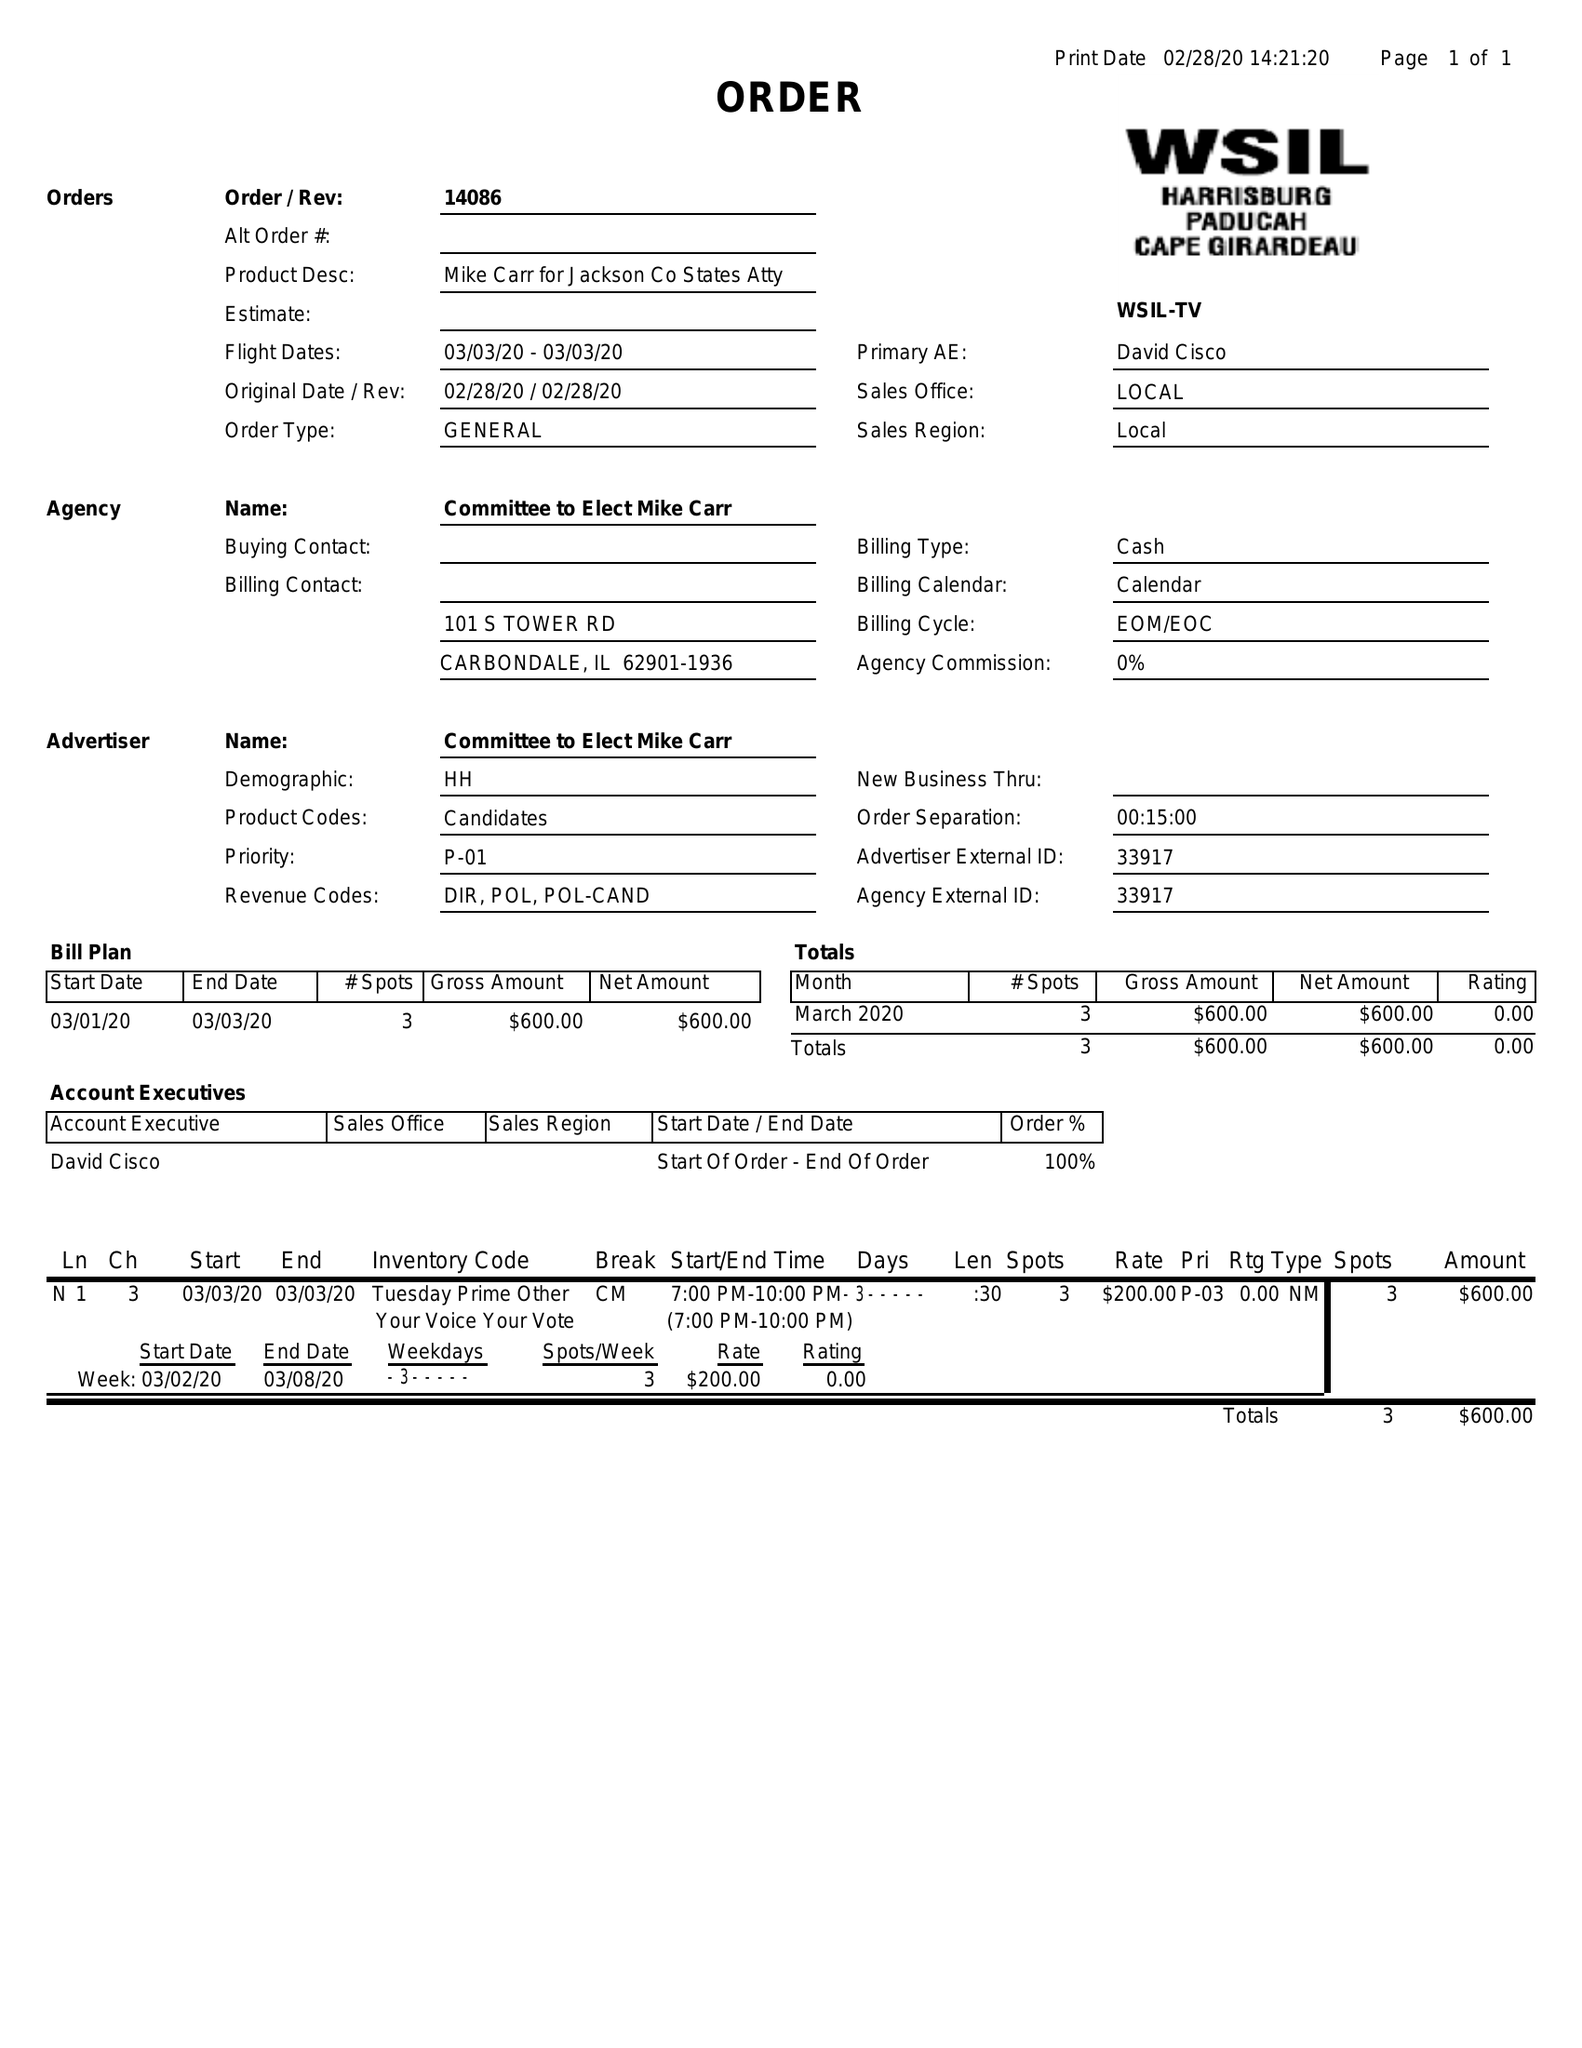What is the value for the advertiser?
Answer the question using a single word or phrase. COMMITTEE TO ELECT MIKE CARR 